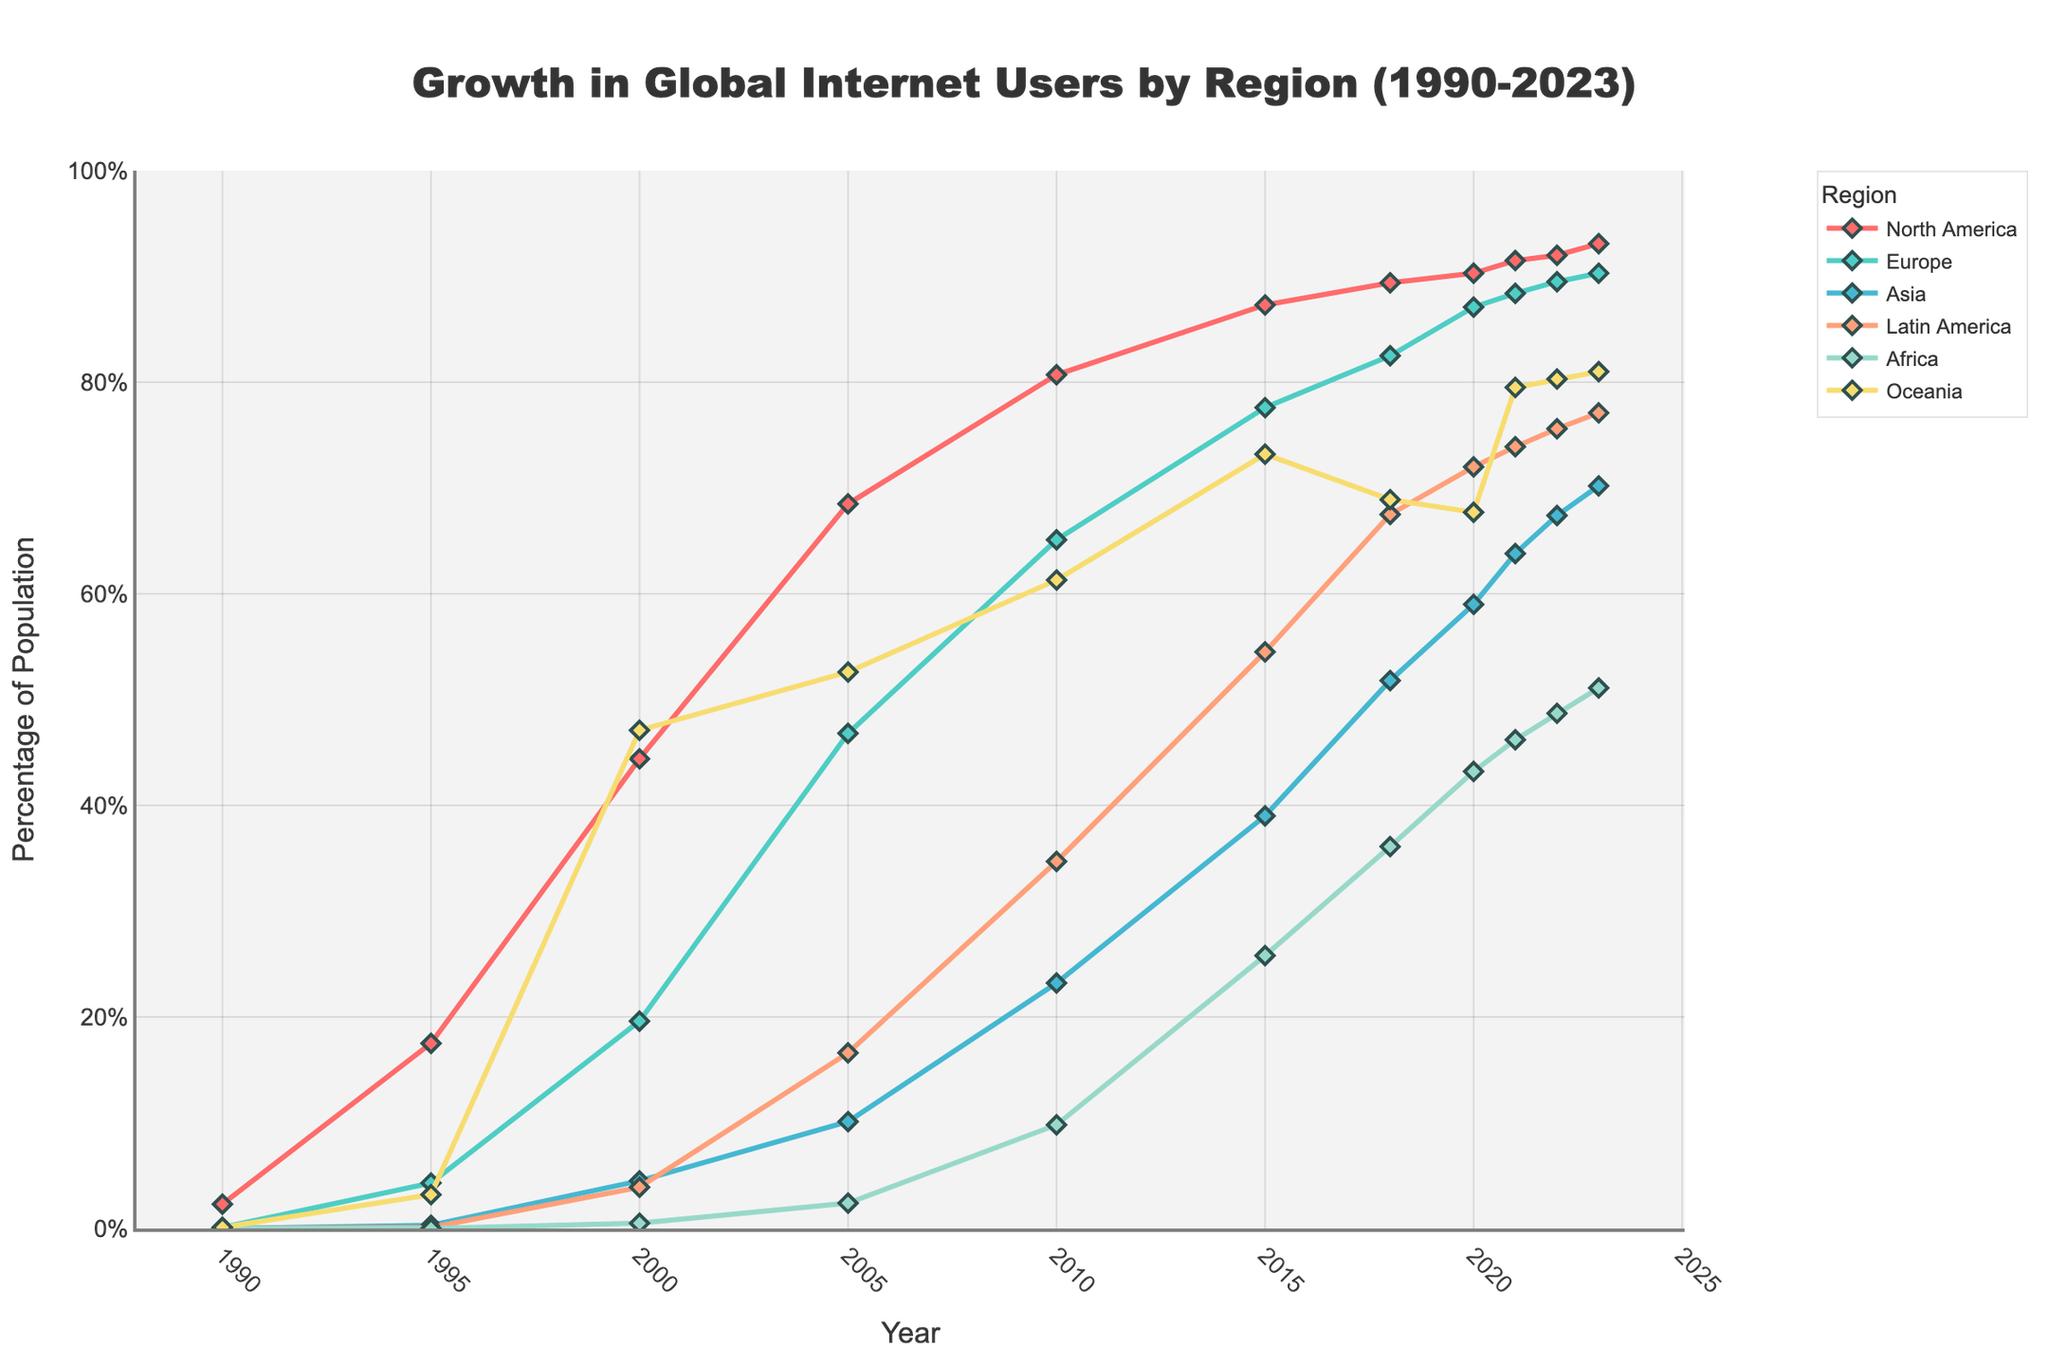What is the general trend of internet user growth in North America from 1990 to 2023? Look at the plotted line for North America. The line shows a clear upward trend from 1990 to 2023, indicating a consistent increase in the percentage of internet users.
Answer: General upward trend Which region had the highest percentage of internet users in 2000 and what was the percentage? Locate the data for the year 2000 across all regions. Oceania had the highest percentage of internet users, indicated by the highest point on the chart for that year. The exact value is about 47.1%.
Answer: Oceania, 47.1% Which two regions had the closest percentage of internet users in 2021? Compare the data points for each region in 2021 and identify the two closest values. Europe and Asia have the percentages of 88.4% and 63.8% respectively, but Latin America and Oceania are closer at 73.9% and 79.5%.
Answer: Latin America and Oceania Which region experienced the most rapid growth in internet users from 1995 to 2005? Identify the growth by subtracting the 1995 value from the 2005 value for each region. Asia's growth is 10.1% - 0.3%, a significant increase compared to others.
Answer: Asia What year did Europe surpass 50% internet usage, and how can you tell? Locate the Europe line and find the first year where the data point rises above 50%. This occurs between 2000 and 2005, specifically in 2005.
Answer: 2005 How do the trends in internet usage for Asia and Latin America compare from 2005 to 2023? Follow the lines for Asia and Latin America from 2005 to 2023. Both exhibit an increasing trend, but Asia shows steeper growth, suggesting faster adoption.
Answer: Asia increased faster Which region shows the least growth from 1990 to 2000, and what is the overall percentage increase? Compare the growth of each region from 1990 to 2000. North America's increase is from 2.3% to 44.4%, Europe from 0.1% to 19.6%, Asia from 0.0% to 4.5%, Latin America from 0.0% to 3.9%, Africa from 0.0% to 0.5%, and Oceania from 0.1% to 47.1%. Africa shows the least growth. The overall increase is 0.5% - 0.0% = 0.5%.
Answer: Africa, 0.5% 